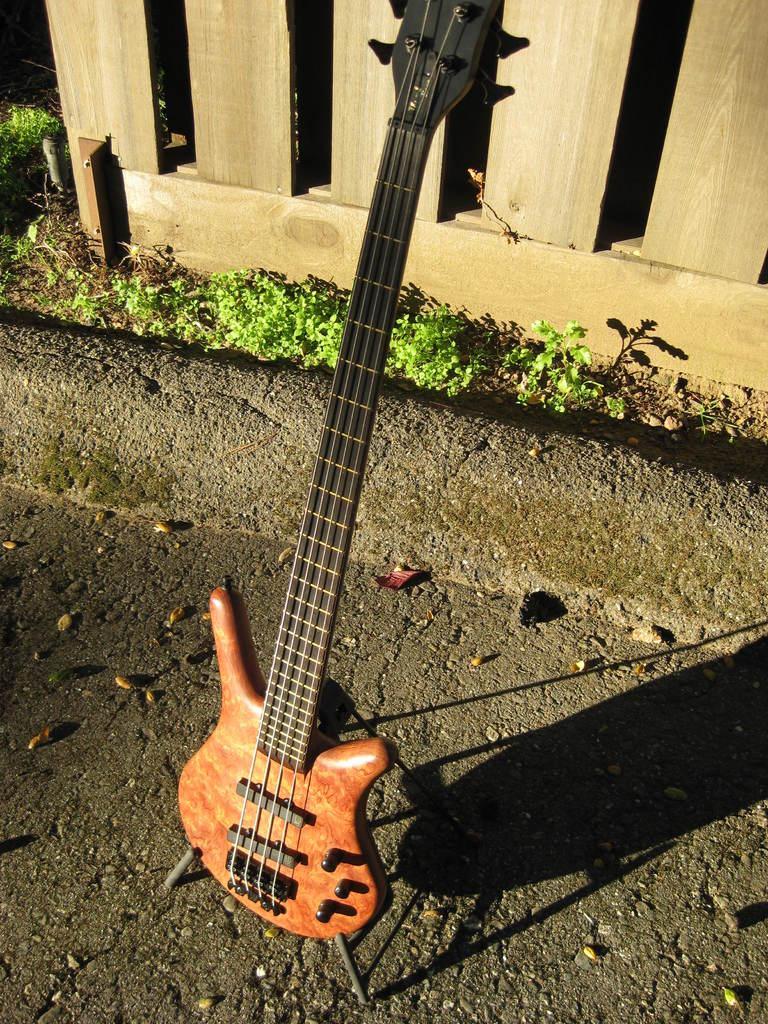How would you summarize this image in a sentence or two? In the image we can see there is a guitar which is standing on road. 